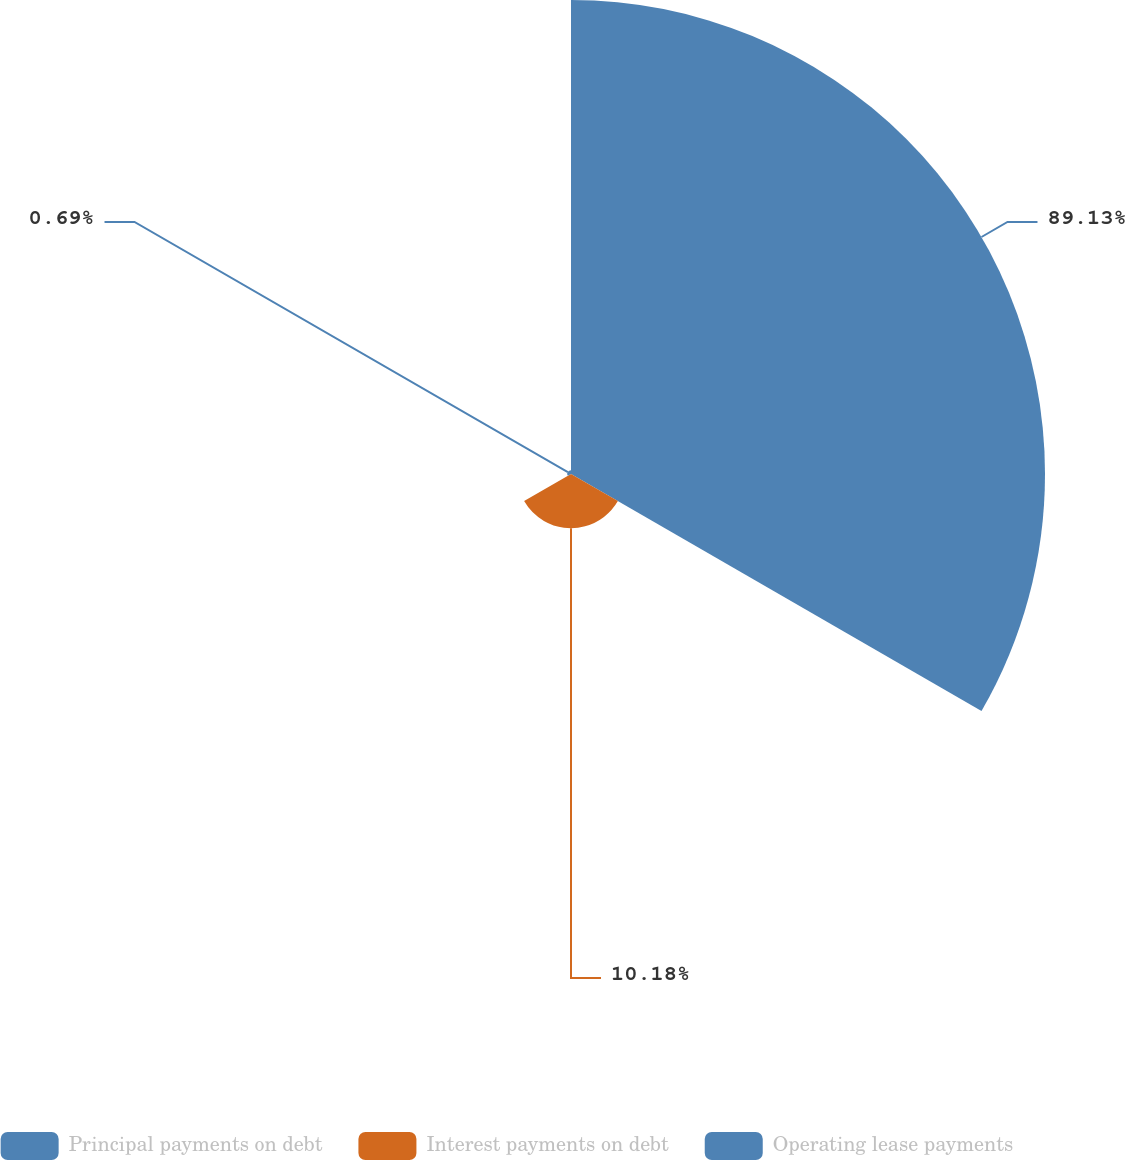<chart> <loc_0><loc_0><loc_500><loc_500><pie_chart><fcel>Principal payments on debt<fcel>Interest payments on debt<fcel>Operating lease payments<nl><fcel>89.13%<fcel>10.18%<fcel>0.69%<nl></chart> 